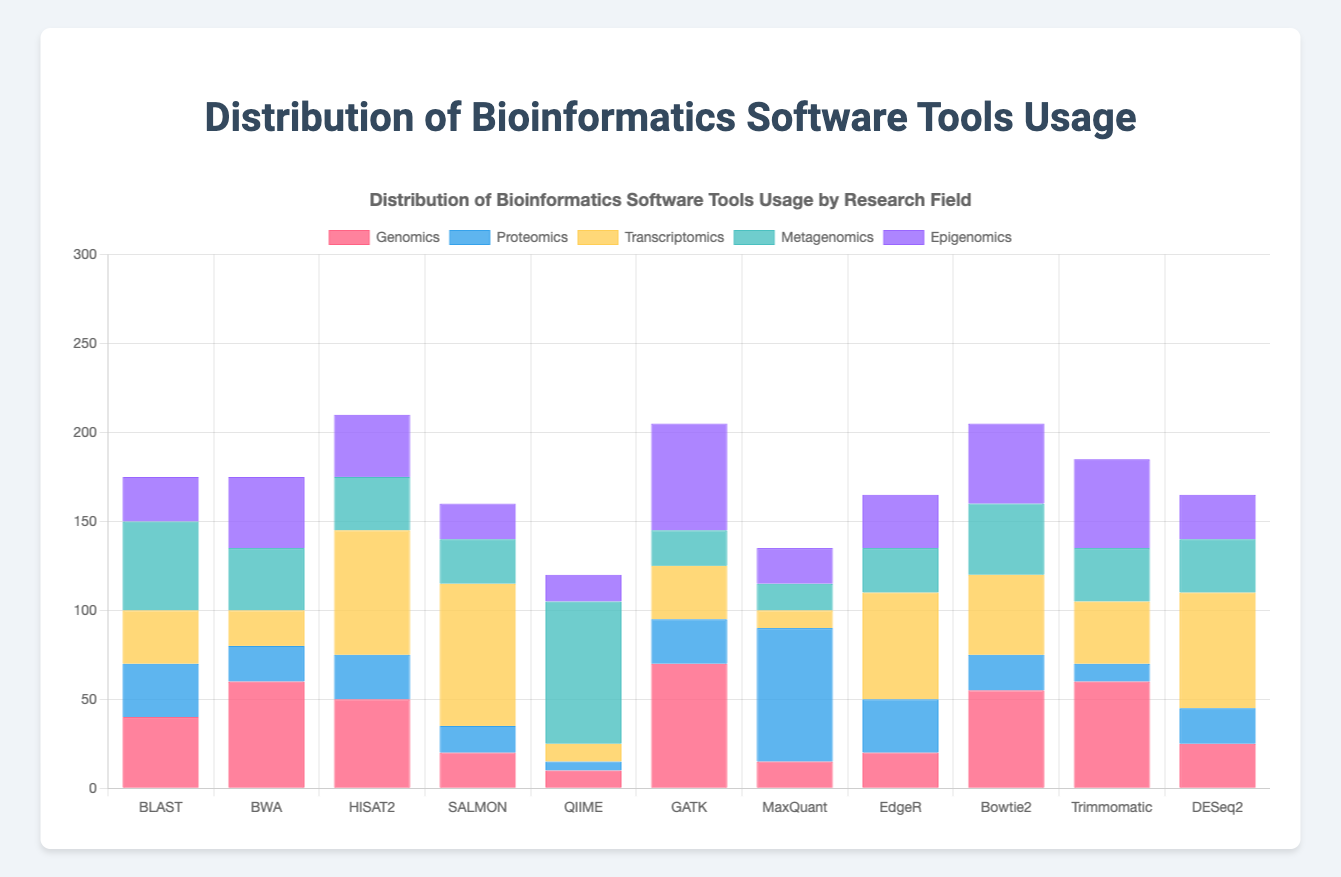Which tool is most widely used in Genomics? To determine the tool most widely used in Genomics, compare the height of the Genomics section for each tool. The tool with the tallest Genomics bar is GATK, with 70 units.
Answer: GATK How does the total usage of DESeq2 compare across all fields? Sum the heights of DESeq2 usage across all fields: 25 (Genomics) + 20 (Proteomics) + 65 (Transcriptomics) + 30 (Metagenomics) + 25 (Epigenomics) = 165 units.
Answer: 165 Which research field sees the least usage of QIIME? Compare the heights for QIIME across all research fields. The shortest bar is for Proteomics with 5 units.
Answer: Proteomics What is the combined usage of SALMON in Genomics and Transcriptomics? Add the heights of SALMON usage in Genomics and Transcriptomics: 20 (Genomics) + 80 (Transcriptomics) = 100 units.
Answer: 100 How does usage of BLAST in Metagenomics compare to its usage in Epigenomics? Compare the heights of BLAST usage in Metagenomics and Epigenomics. Metagenomics is 50 units while Epigenomics is 25 units.
Answer: BLAST is used twice as much in Metagenomics as in Epigenomics What is the average usage of HISAT2 across all research fields? Sum the heights of HISAT2 across all fields and then divide by the number of fields: (50 + 25 + 70 + 30 + 35) / 5 = 210 / 5 = 42 units.
Answer: 42 Which tool has the highest usage in a single research field, and what is that field? Look for the highest single bar in any field. SALMON in Transcriptomics has the highest usage at 80 units.
Answer: SALMON in Transcriptomics In which research field is GATK predominantly used? Compare the heights of GATK usage in all fields. The tallest bar for GATK is in Genomics with 70 units.
Answer: Genomics Which tool has the second-highest usage in Proteomics? List the usage of all tools in Proteomics and rank them. MaxQuant is the highest with 75 units, followed by BLAST and EdgeR both with 30 units. Therefore, BLAST or EdgeR is second highest.
Answer: BLAST or EdgeR What is the difference in usage of Bowtie2 between Metagenomics and Epigenomics? Subtract the height of Bowtie2 usage in Epigenomics from its usage in Metagenomics: 40 (Metagenomics) - 45 (Epigenomics) = -5 units.
Answer: -5 units 